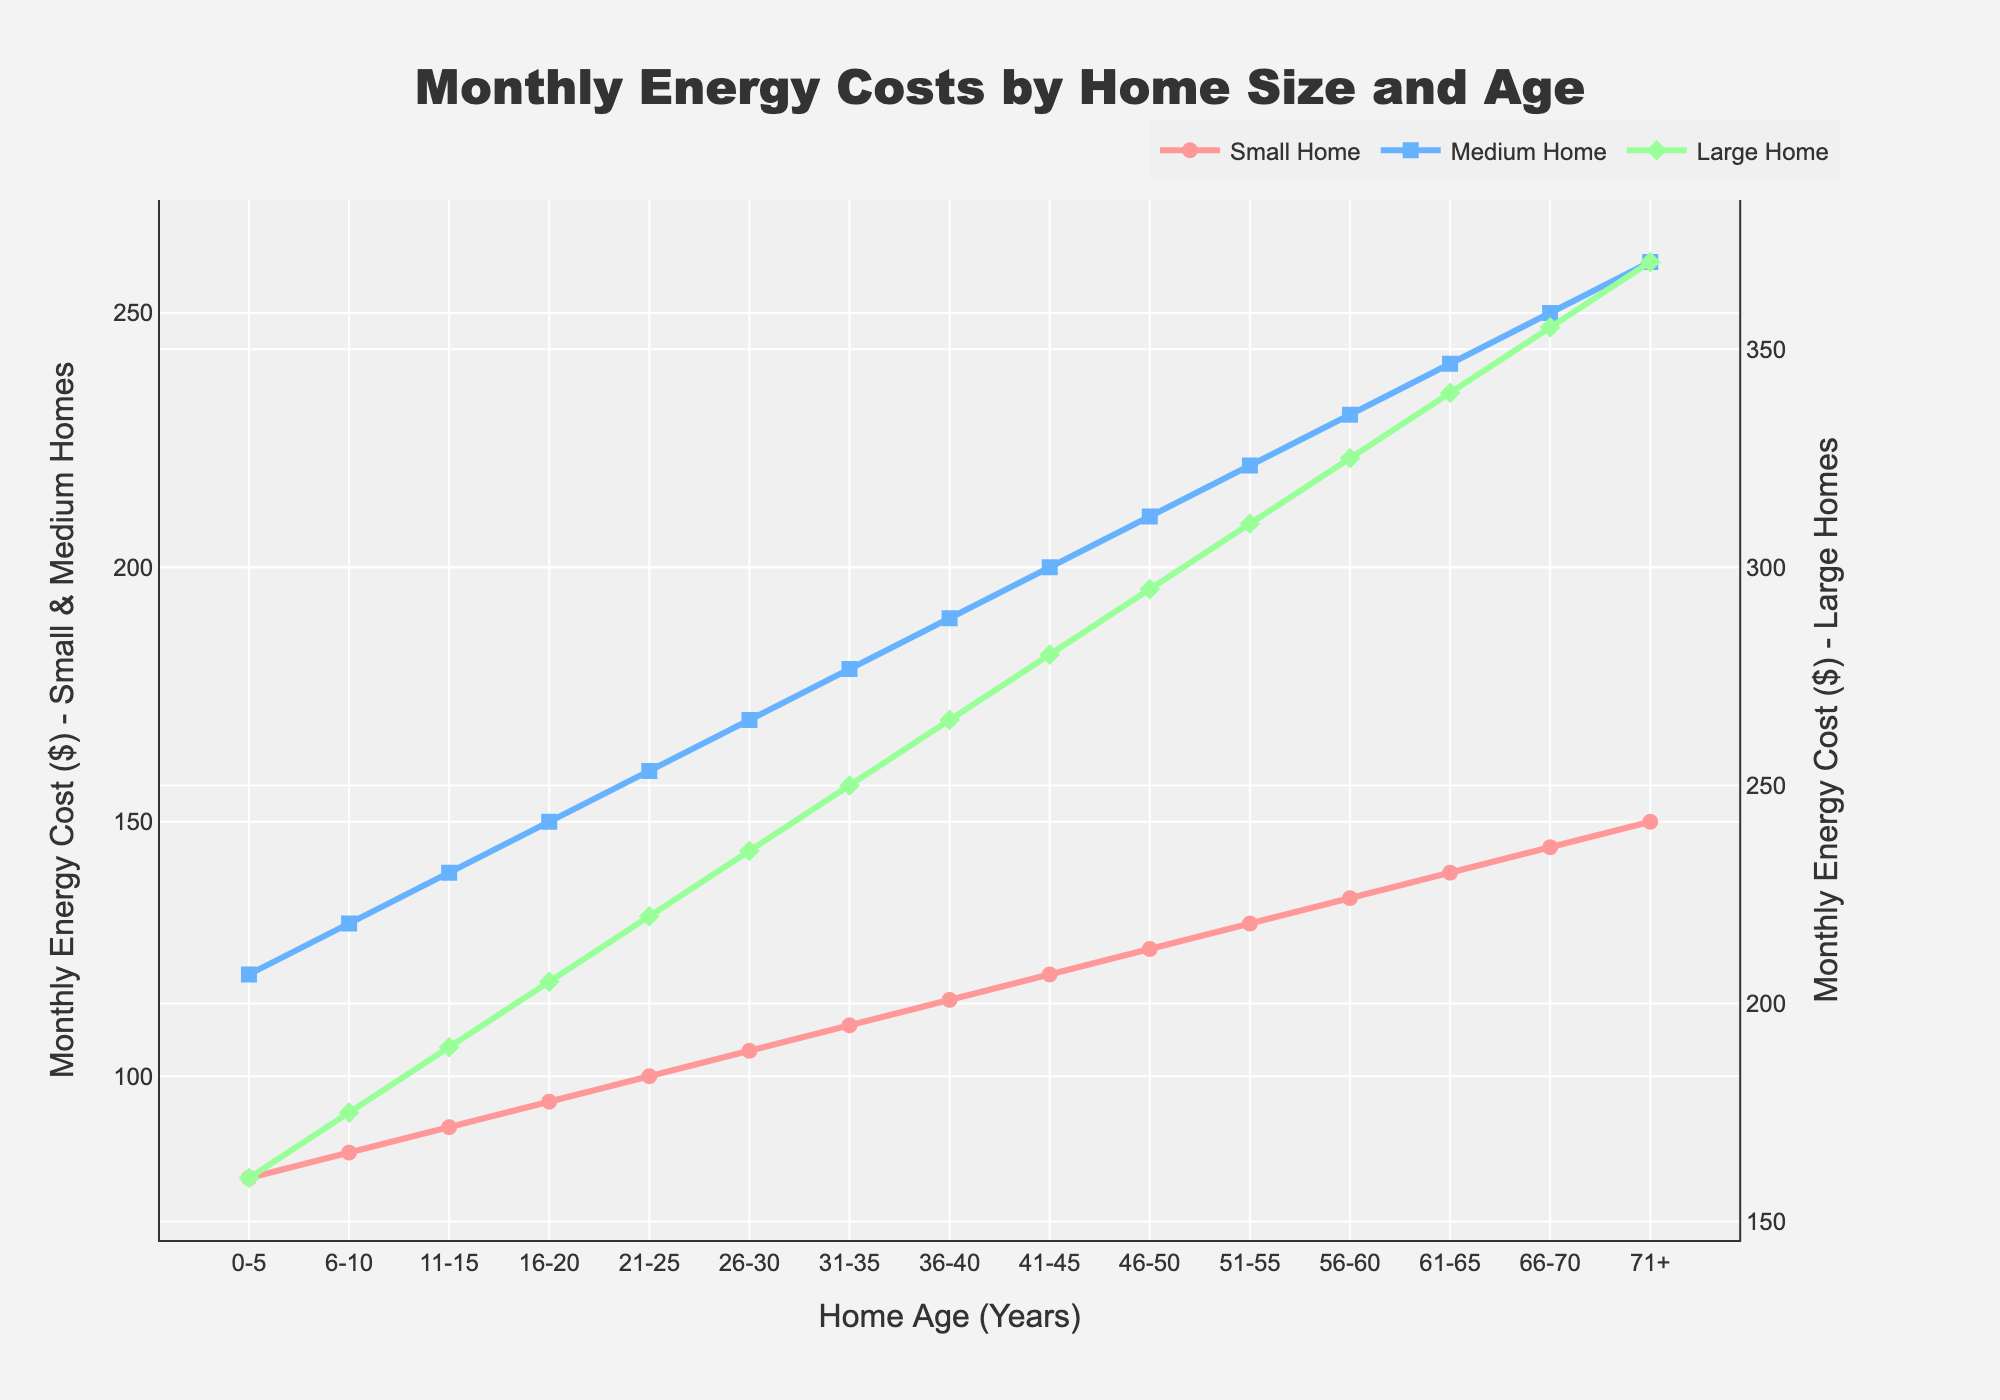Which home size has the highest monthly energy cost for homes aged 71+? To answer this, refer to the line chart and look at the age group 71+ for all home sizes. The cost for the Small Home is $150, the Medium Home is $260, and the Large Home is $370. The Large Home has the highest energy cost.
Answer: Large Home What's the difference in monthly energy costs between homes aged 0-5 and 71+ for Medium Homes? Check the monthly energy costs for Medium Homes in the 0-5 and 71+ age groups. For 0-5 years, it's $120, and for 71+, it's $260. Subtract the two values: $260 - $120.
Answer: $140 In which age category does Medium Home first exceed $200 in monthly energy costs? Track the monthly costs of Medium Homes across the age categories and identify where it first exceeds $200. It first exceeds $200 at the 41-45 years age category with a cost of $200.
Answer: 41-45 How do the monthly energy costs for Small and Large Homes compare for homes aged 26-30? Look at the monthly energy costs for the 26-30 age group for both Small and Large Homes. The Small Home has $105 and the Large Home has $235.
Answer: Large Home is higher by $130 What's the average monthly energy cost for Medium Homes across all age groups? Add up the monthly energy costs for Medium Homes across all age groups and divide by the number of age groups. The sums are: 120 + 130 + 140 + 150 + 160 + 170 + 180 + 190 + 200 + 210 + 220 + 230 + 240 + 250 + 260 = 2950. There are 15 age groups. The average is 2950 / 15.
Answer: $196.67 Which home size experiences the steepest increase in monthly energy costs from age 0-5 to 71+? Calculate the change in energy costs for each home size from age 0-5 to 71+: 
- Small Home: $150 - $80 = $70,
- Medium Home: $260 - $120 = $140,
- Large Home: $370 - $160 = $210.
The Large Home has the steepest increase.
Answer: Large Home Explain the trend in monthly energy costs for Large Homes as they age. Examine the monthly energy cost values for Large Homes from 0-5 years to 71+. The costs start at $160 and increase continuously with age, reaching $370 for homes aged 71+. The trend indicates a consistent rise in costs as the home ages.
Answer: Costs increase with age 